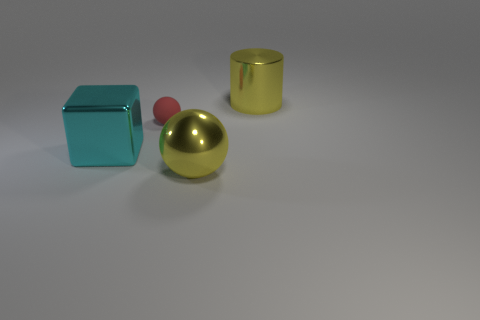How would you describe the lighting and the shadows in the scene? The scene is softly lit from a direction that is not directly visible in the image, creating gentle shadows that help define the shapes of the objects. The shadows are diffuse, indicating the light source could be an artificial soft box or a window diffusing the sunlight. If these objects were part of a larger scene, what kind of environment do you imagine they would fit into? Considering their simplistic yet elegant design, these objects could be part of a modern minimalist interior design setting, perhaps as decorative pieces on a sleek surface or as part of a conceptual art installation. 